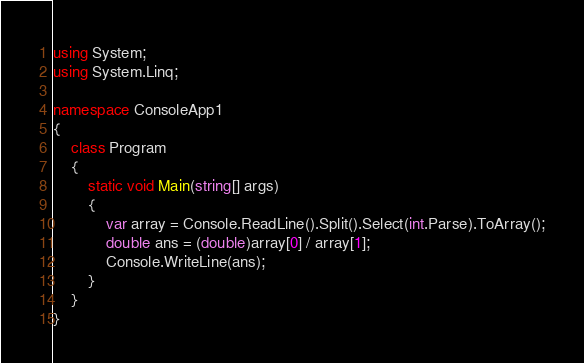Convert code to text. <code><loc_0><loc_0><loc_500><loc_500><_C#_>using System;
using System.Linq;

namespace ConsoleApp1
{
    class Program
    {
        static void Main(string[] args)
        {
            var array = Console.ReadLine().Split().Select(int.Parse).ToArray();
            double ans = (double)array[0] / array[1];
            Console.WriteLine(ans);
        }
    }
}</code> 